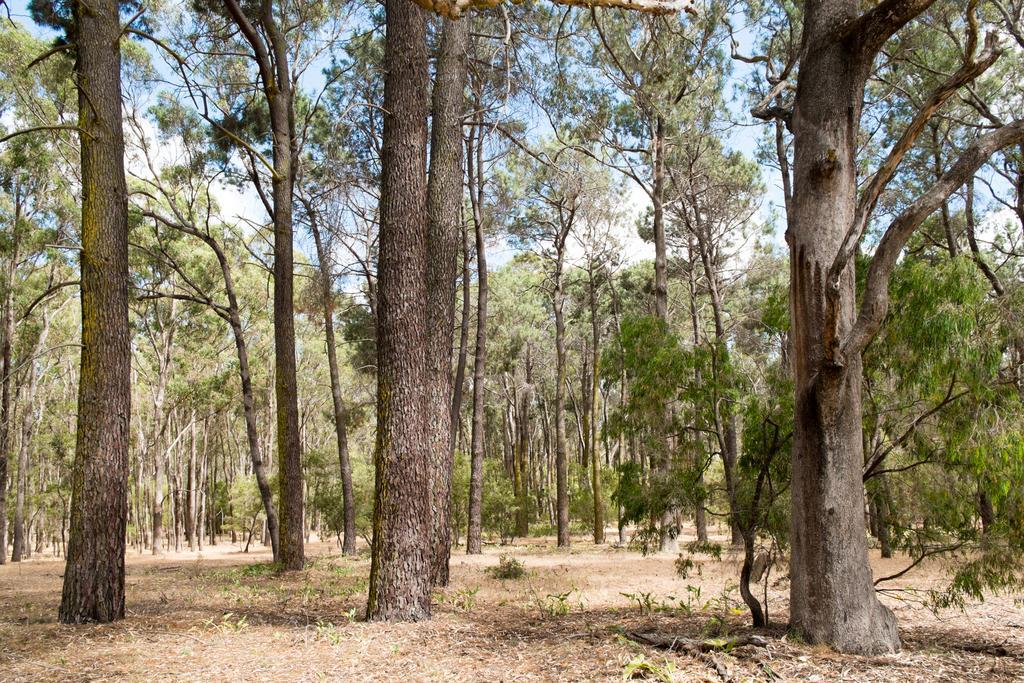Could you give a brief overview of what you see in this image? In this image I can see trees, plants and also there is sky. 